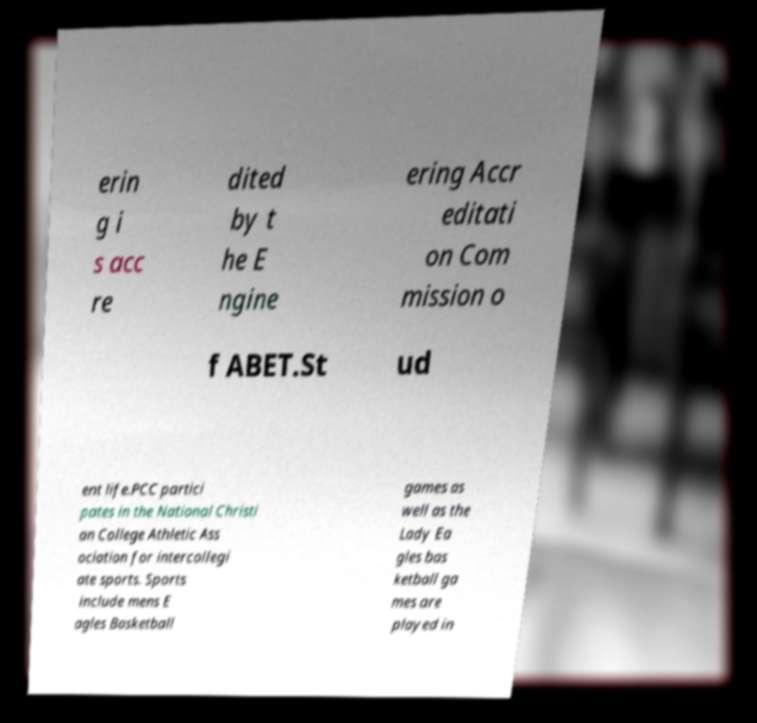Can you accurately transcribe the text from the provided image for me? erin g i s acc re dited by t he E ngine ering Accr editati on Com mission o f ABET.St ud ent life.PCC partici pates in the National Christi an College Athletic Ass ociation for intercollegi ate sports. Sports include mens E agles Basketball games as well as the Lady Ea gles bas ketball ga mes are played in 